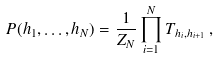Convert formula to latex. <formula><loc_0><loc_0><loc_500><loc_500>P ( h _ { 1 } , \dots , h _ { N } ) = \frac { 1 } { Z _ { N } } \prod _ { i = 1 } ^ { N } T _ { h _ { i } , h _ { i + 1 } } \, ,</formula> 